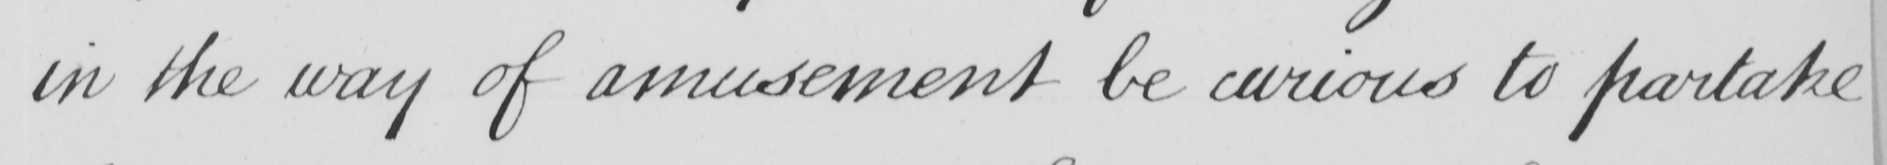Can you tell me what this handwritten text says? in the way of amusement be curious to partake 